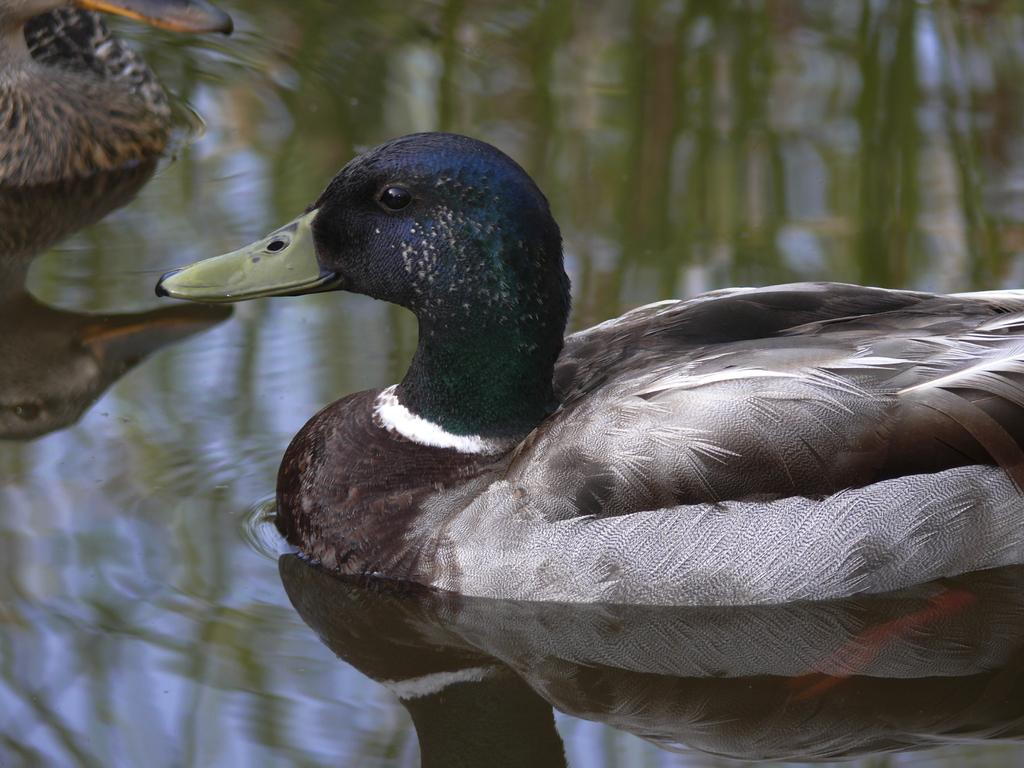Where was the picture taken? The picture was clicked outside. What animals can be seen in the image? There are two birds in the image. What type of birds are they? The birds appear to be ducks. Where are the ducks located in the image? The ducks are in a water body. What can be observed on the surface of the water body? There are reflections of objects visible on the water body. What story is the crook telling the shoe in the image? There is no crook or shoe present in the image; it features two ducks in a water body. 